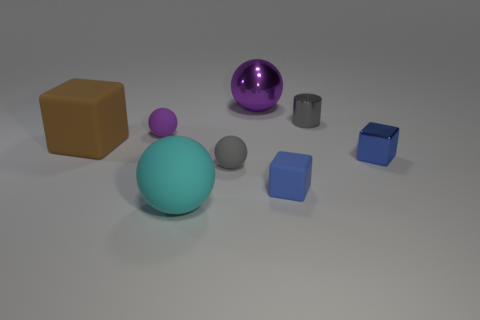Is the number of blue cubes that are behind the tiny blue shiny thing the same as the number of big purple shiny objects to the right of the big brown thing? no 